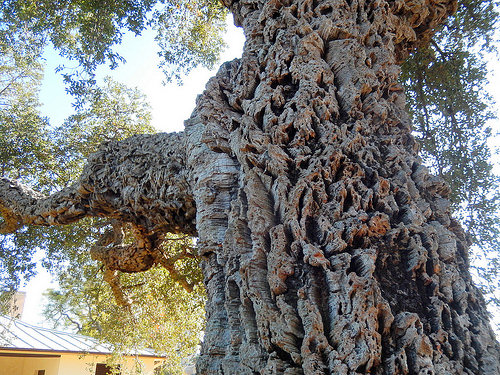<image>
Can you confirm if the house is under the tree? No. The house is not positioned under the tree. The vertical relationship between these objects is different. 